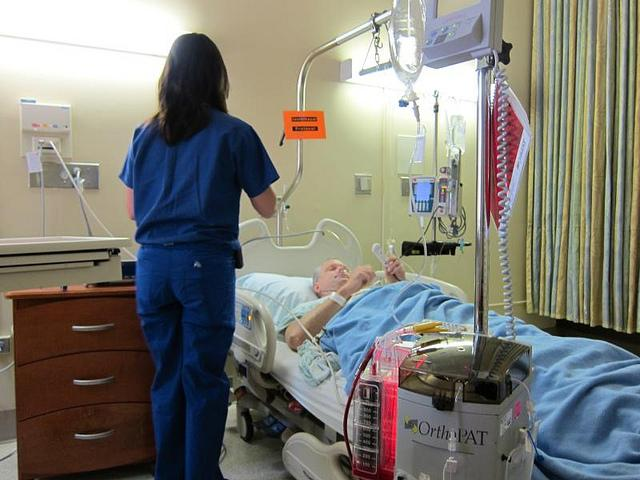Where is the man laying? hospital bed 